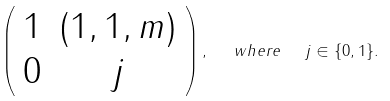<formula> <loc_0><loc_0><loc_500><loc_500>\left ( \begin{array} { c c } 1 & ( 1 , 1 , m ) \\ 0 & j \end{array} \right ) , \ \ w h e r e \ \ j \in \{ 0 , 1 \} .</formula> 